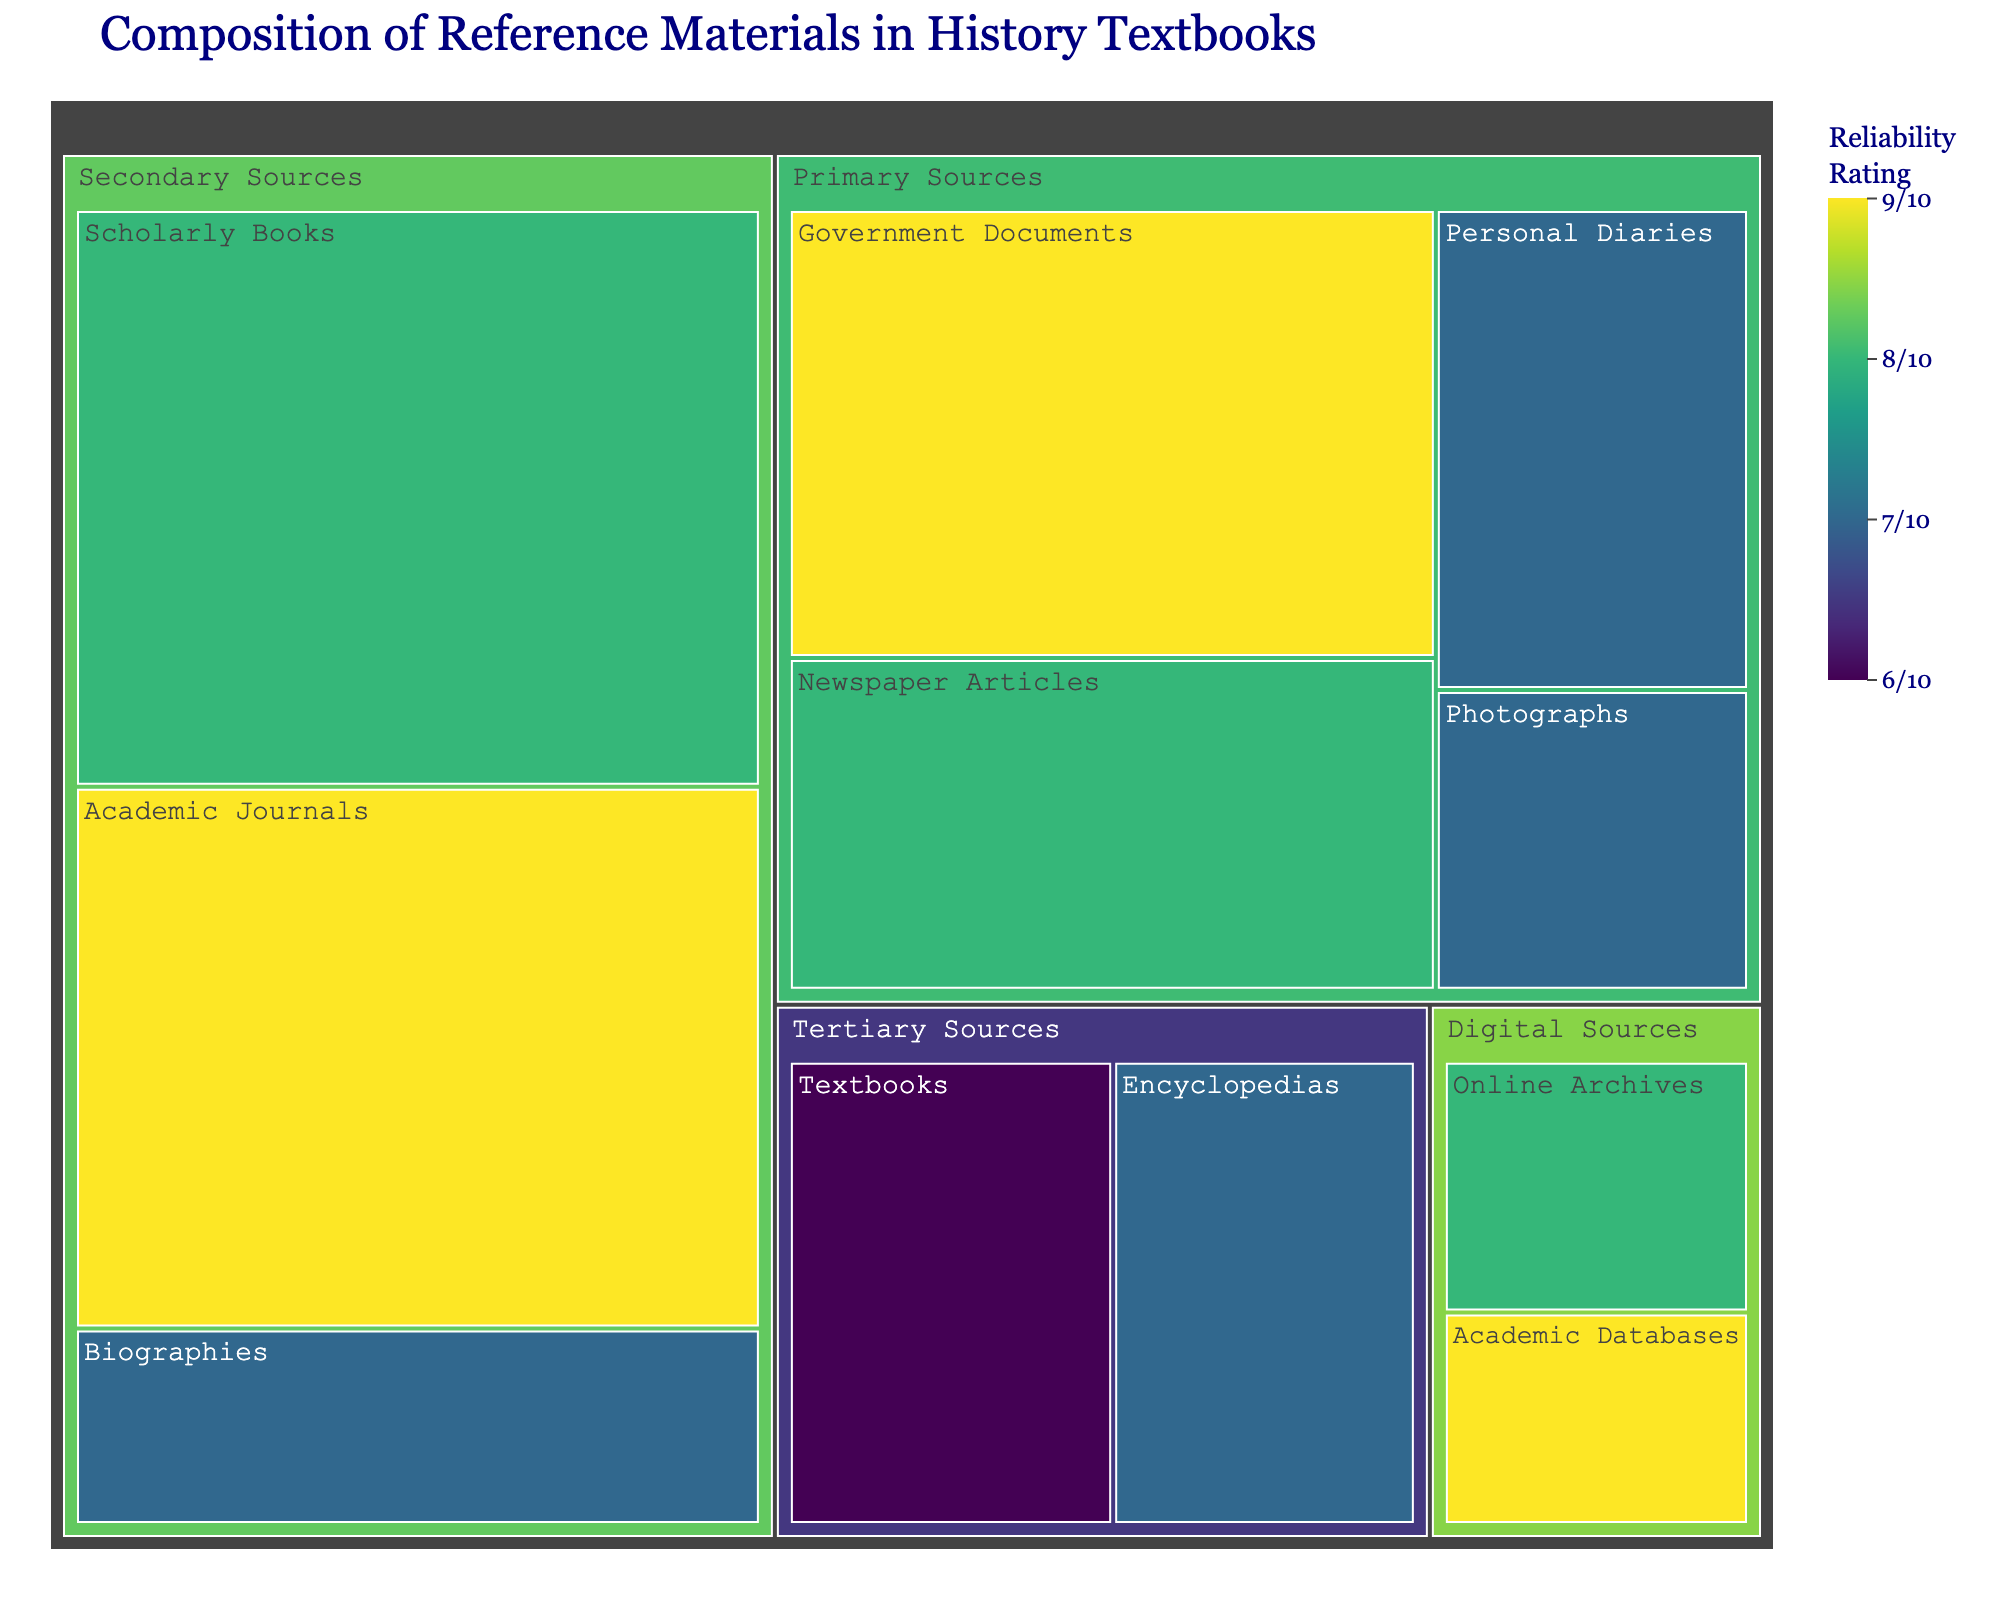What is the title of the treemap? The title is displayed prominently at the top of the figure, summarizing its main theme.
Answer: Composition of Reference Materials in History Textbooks Which category has the highest reliability rating overall? The treemap uses color to represent the reliability rating. The deepest color signifies the highest rating, which corresponds to the Academic Journals in the Secondary Sources category.
Answer: Secondary Sources What type of primary source has the highest reliability rating? Primary Sources have different types listed under them. By checking the reliability rating of each, Government Documents stand out with the highest rating of 9.
Answer: Government Documents How much percentage of reference materials do Academic Journals contribute? Hovering over the Academic Journals section reveals its percentage contribution.
Answer: 15% Compare the reliability ratings of Textbooks and Encyclopedias. Which one is higher? Both fall under the Tertiary Sources category. Textbooks have a reliability rating of 6, whereas Encyclopedias have a rating of 7.
Answer: Encyclopedias What is the combined percentage of Newspaper Articles and Personal Diaries from primary sources? Primary sources include both types with percentages 10% and 8%, respectively. Adding these gives 18%.
Answer: 18% Identify the source type with the lowest reliability rating under Digital Sources. Within Digital Sources, the two types listed are Online Archives (8) and Academic Databases (9). The lowest among these is hence Online Archives.
Answer: Online Archives What is the total percentage of Tertiary Sources? Summing up the percentages of Textbooks (10%) and Encyclopedias (8%) under Tertiary Sources gives a total percentage of 18%.
Answer: 18% Which type of source has the smallest percentage in the treemap? By inspecting the hover data for each type, Academic Databases under Digital Sources has the smallest contribution at 3%.
Answer: Academic Databases What primary source has a lower reliability rating: Photographs or Newspaper Articles? Comparing the listed ratings for both, Photographs have a rating of 7, and Newspaper Articles have a rating of 8, so Photographs have a lower rating.
Answer: Photographs 